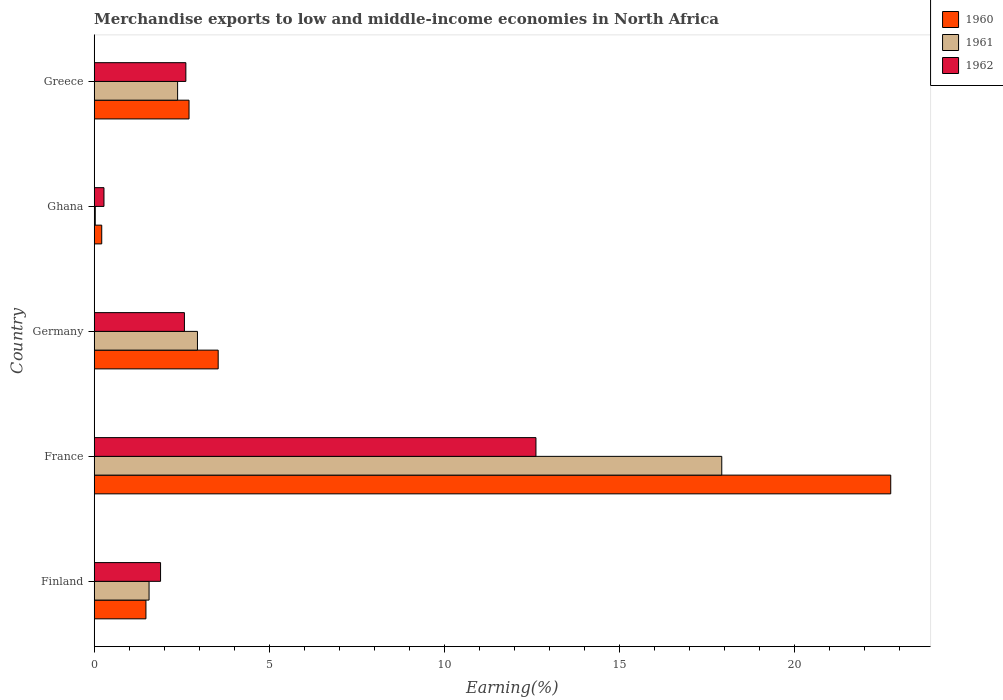How many different coloured bars are there?
Make the answer very short. 3. How many groups of bars are there?
Offer a terse response. 5. Are the number of bars per tick equal to the number of legend labels?
Your answer should be very brief. Yes. How many bars are there on the 3rd tick from the bottom?
Your answer should be very brief. 3. What is the percentage of amount earned from merchandise exports in 1960 in Greece?
Ensure brevity in your answer.  2.71. Across all countries, what is the maximum percentage of amount earned from merchandise exports in 1960?
Your response must be concise. 22.75. Across all countries, what is the minimum percentage of amount earned from merchandise exports in 1961?
Your answer should be compact. 0.03. In which country was the percentage of amount earned from merchandise exports in 1962 maximum?
Your answer should be very brief. France. In which country was the percentage of amount earned from merchandise exports in 1961 minimum?
Your answer should be compact. Ghana. What is the total percentage of amount earned from merchandise exports in 1960 in the graph?
Your answer should be compact. 30.69. What is the difference between the percentage of amount earned from merchandise exports in 1960 in France and that in Greece?
Provide a short and direct response. 20.04. What is the difference between the percentage of amount earned from merchandise exports in 1961 in France and the percentage of amount earned from merchandise exports in 1960 in Finland?
Ensure brevity in your answer.  16.44. What is the average percentage of amount earned from merchandise exports in 1960 per country?
Ensure brevity in your answer.  6.14. What is the difference between the percentage of amount earned from merchandise exports in 1961 and percentage of amount earned from merchandise exports in 1960 in Ghana?
Provide a short and direct response. -0.18. What is the ratio of the percentage of amount earned from merchandise exports in 1961 in Ghana to that in Greece?
Make the answer very short. 0.01. What is the difference between the highest and the second highest percentage of amount earned from merchandise exports in 1962?
Ensure brevity in your answer.  10. What is the difference between the highest and the lowest percentage of amount earned from merchandise exports in 1962?
Your answer should be compact. 12.34. In how many countries, is the percentage of amount earned from merchandise exports in 1961 greater than the average percentage of amount earned from merchandise exports in 1961 taken over all countries?
Your answer should be compact. 1. Is it the case that in every country, the sum of the percentage of amount earned from merchandise exports in 1960 and percentage of amount earned from merchandise exports in 1961 is greater than the percentage of amount earned from merchandise exports in 1962?
Ensure brevity in your answer.  No. How many bars are there?
Your answer should be compact. 15. How many countries are there in the graph?
Ensure brevity in your answer.  5. What is the difference between two consecutive major ticks on the X-axis?
Offer a terse response. 5. Does the graph contain any zero values?
Give a very brief answer. No. How are the legend labels stacked?
Give a very brief answer. Vertical. What is the title of the graph?
Provide a succinct answer. Merchandise exports to low and middle-income economies in North Africa. What is the label or title of the X-axis?
Keep it short and to the point. Earning(%). What is the Earning(%) in 1960 in Finland?
Your answer should be compact. 1.48. What is the Earning(%) in 1961 in Finland?
Make the answer very short. 1.57. What is the Earning(%) in 1962 in Finland?
Keep it short and to the point. 1.9. What is the Earning(%) in 1960 in France?
Provide a short and direct response. 22.75. What is the Earning(%) of 1961 in France?
Your answer should be very brief. 17.92. What is the Earning(%) in 1962 in France?
Offer a terse response. 12.62. What is the Earning(%) of 1960 in Germany?
Your answer should be compact. 3.54. What is the Earning(%) in 1961 in Germany?
Your response must be concise. 2.95. What is the Earning(%) of 1962 in Germany?
Your response must be concise. 2.58. What is the Earning(%) of 1960 in Ghana?
Your answer should be compact. 0.22. What is the Earning(%) in 1961 in Ghana?
Provide a short and direct response. 0.03. What is the Earning(%) in 1962 in Ghana?
Offer a terse response. 0.28. What is the Earning(%) in 1960 in Greece?
Provide a short and direct response. 2.71. What is the Earning(%) of 1961 in Greece?
Provide a short and direct response. 2.38. What is the Earning(%) of 1962 in Greece?
Your answer should be very brief. 2.62. Across all countries, what is the maximum Earning(%) of 1960?
Keep it short and to the point. 22.75. Across all countries, what is the maximum Earning(%) in 1961?
Keep it short and to the point. 17.92. Across all countries, what is the maximum Earning(%) of 1962?
Provide a short and direct response. 12.62. Across all countries, what is the minimum Earning(%) in 1960?
Offer a terse response. 0.22. Across all countries, what is the minimum Earning(%) in 1961?
Your answer should be very brief. 0.03. Across all countries, what is the minimum Earning(%) of 1962?
Provide a succinct answer. 0.28. What is the total Earning(%) of 1960 in the graph?
Make the answer very short. 30.69. What is the total Earning(%) of 1961 in the graph?
Keep it short and to the point. 24.85. What is the total Earning(%) in 1962 in the graph?
Give a very brief answer. 19.98. What is the difference between the Earning(%) of 1960 in Finland and that in France?
Make the answer very short. -21.27. What is the difference between the Earning(%) in 1961 in Finland and that in France?
Keep it short and to the point. -16.36. What is the difference between the Earning(%) in 1962 in Finland and that in France?
Your answer should be compact. -10.72. What is the difference between the Earning(%) of 1960 in Finland and that in Germany?
Your answer should be compact. -2.06. What is the difference between the Earning(%) of 1961 in Finland and that in Germany?
Your answer should be very brief. -1.38. What is the difference between the Earning(%) of 1962 in Finland and that in Germany?
Offer a terse response. -0.68. What is the difference between the Earning(%) of 1960 in Finland and that in Ghana?
Your response must be concise. 1.26. What is the difference between the Earning(%) of 1961 in Finland and that in Ghana?
Offer a terse response. 1.54. What is the difference between the Earning(%) of 1962 in Finland and that in Ghana?
Offer a very short reply. 1.62. What is the difference between the Earning(%) of 1960 in Finland and that in Greece?
Provide a succinct answer. -1.23. What is the difference between the Earning(%) of 1961 in Finland and that in Greece?
Give a very brief answer. -0.82. What is the difference between the Earning(%) in 1962 in Finland and that in Greece?
Provide a succinct answer. -0.72. What is the difference between the Earning(%) of 1960 in France and that in Germany?
Ensure brevity in your answer.  19.21. What is the difference between the Earning(%) of 1961 in France and that in Germany?
Your response must be concise. 14.97. What is the difference between the Earning(%) in 1962 in France and that in Germany?
Keep it short and to the point. 10.04. What is the difference between the Earning(%) of 1960 in France and that in Ghana?
Keep it short and to the point. 22.53. What is the difference between the Earning(%) of 1961 in France and that in Ghana?
Give a very brief answer. 17.89. What is the difference between the Earning(%) of 1962 in France and that in Ghana?
Offer a very short reply. 12.34. What is the difference between the Earning(%) in 1960 in France and that in Greece?
Give a very brief answer. 20.04. What is the difference between the Earning(%) of 1961 in France and that in Greece?
Provide a succinct answer. 15.54. What is the difference between the Earning(%) of 1962 in France and that in Greece?
Your answer should be very brief. 10. What is the difference between the Earning(%) in 1960 in Germany and that in Ghana?
Provide a short and direct response. 3.33. What is the difference between the Earning(%) in 1961 in Germany and that in Ghana?
Provide a short and direct response. 2.92. What is the difference between the Earning(%) of 1962 in Germany and that in Ghana?
Give a very brief answer. 2.3. What is the difference between the Earning(%) of 1960 in Germany and that in Greece?
Your response must be concise. 0.83. What is the difference between the Earning(%) of 1961 in Germany and that in Greece?
Ensure brevity in your answer.  0.57. What is the difference between the Earning(%) of 1962 in Germany and that in Greece?
Your answer should be compact. -0.04. What is the difference between the Earning(%) in 1960 in Ghana and that in Greece?
Keep it short and to the point. -2.49. What is the difference between the Earning(%) in 1961 in Ghana and that in Greece?
Provide a short and direct response. -2.35. What is the difference between the Earning(%) in 1962 in Ghana and that in Greece?
Provide a short and direct response. -2.34. What is the difference between the Earning(%) in 1960 in Finland and the Earning(%) in 1961 in France?
Provide a succinct answer. -16.44. What is the difference between the Earning(%) in 1960 in Finland and the Earning(%) in 1962 in France?
Make the answer very short. -11.14. What is the difference between the Earning(%) of 1961 in Finland and the Earning(%) of 1962 in France?
Your answer should be very brief. -11.05. What is the difference between the Earning(%) of 1960 in Finland and the Earning(%) of 1961 in Germany?
Offer a very short reply. -1.47. What is the difference between the Earning(%) of 1960 in Finland and the Earning(%) of 1962 in Germany?
Your answer should be compact. -1.1. What is the difference between the Earning(%) of 1961 in Finland and the Earning(%) of 1962 in Germany?
Your response must be concise. -1.01. What is the difference between the Earning(%) of 1960 in Finland and the Earning(%) of 1961 in Ghana?
Your answer should be very brief. 1.45. What is the difference between the Earning(%) in 1960 in Finland and the Earning(%) in 1962 in Ghana?
Make the answer very short. 1.2. What is the difference between the Earning(%) of 1961 in Finland and the Earning(%) of 1962 in Ghana?
Provide a succinct answer. 1.29. What is the difference between the Earning(%) of 1960 in Finland and the Earning(%) of 1961 in Greece?
Give a very brief answer. -0.9. What is the difference between the Earning(%) of 1960 in Finland and the Earning(%) of 1962 in Greece?
Your answer should be compact. -1.14. What is the difference between the Earning(%) in 1961 in Finland and the Earning(%) in 1962 in Greece?
Your answer should be compact. -1.05. What is the difference between the Earning(%) in 1960 in France and the Earning(%) in 1961 in Germany?
Your answer should be very brief. 19.8. What is the difference between the Earning(%) in 1960 in France and the Earning(%) in 1962 in Germany?
Ensure brevity in your answer.  20.17. What is the difference between the Earning(%) in 1961 in France and the Earning(%) in 1962 in Germany?
Your answer should be very brief. 15.35. What is the difference between the Earning(%) of 1960 in France and the Earning(%) of 1961 in Ghana?
Your answer should be compact. 22.72. What is the difference between the Earning(%) of 1960 in France and the Earning(%) of 1962 in Ghana?
Your response must be concise. 22.47. What is the difference between the Earning(%) of 1961 in France and the Earning(%) of 1962 in Ghana?
Give a very brief answer. 17.64. What is the difference between the Earning(%) of 1960 in France and the Earning(%) of 1961 in Greece?
Keep it short and to the point. 20.37. What is the difference between the Earning(%) in 1960 in France and the Earning(%) in 1962 in Greece?
Offer a very short reply. 20.13. What is the difference between the Earning(%) in 1961 in France and the Earning(%) in 1962 in Greece?
Keep it short and to the point. 15.3. What is the difference between the Earning(%) in 1960 in Germany and the Earning(%) in 1961 in Ghana?
Make the answer very short. 3.51. What is the difference between the Earning(%) of 1960 in Germany and the Earning(%) of 1962 in Ghana?
Make the answer very short. 3.26. What is the difference between the Earning(%) of 1961 in Germany and the Earning(%) of 1962 in Ghana?
Your answer should be very brief. 2.67. What is the difference between the Earning(%) of 1960 in Germany and the Earning(%) of 1961 in Greece?
Offer a very short reply. 1.16. What is the difference between the Earning(%) of 1960 in Germany and the Earning(%) of 1962 in Greece?
Your answer should be compact. 0.92. What is the difference between the Earning(%) of 1961 in Germany and the Earning(%) of 1962 in Greece?
Give a very brief answer. 0.33. What is the difference between the Earning(%) of 1960 in Ghana and the Earning(%) of 1961 in Greece?
Your answer should be compact. -2.17. What is the difference between the Earning(%) in 1960 in Ghana and the Earning(%) in 1962 in Greece?
Your answer should be compact. -2.4. What is the difference between the Earning(%) of 1961 in Ghana and the Earning(%) of 1962 in Greece?
Your answer should be compact. -2.59. What is the average Earning(%) of 1960 per country?
Keep it short and to the point. 6.14. What is the average Earning(%) in 1961 per country?
Offer a very short reply. 4.97. What is the average Earning(%) in 1962 per country?
Give a very brief answer. 4. What is the difference between the Earning(%) of 1960 and Earning(%) of 1961 in Finland?
Your answer should be very brief. -0.09. What is the difference between the Earning(%) of 1960 and Earning(%) of 1962 in Finland?
Provide a succinct answer. -0.42. What is the difference between the Earning(%) of 1961 and Earning(%) of 1962 in Finland?
Keep it short and to the point. -0.33. What is the difference between the Earning(%) of 1960 and Earning(%) of 1961 in France?
Provide a short and direct response. 4.83. What is the difference between the Earning(%) of 1960 and Earning(%) of 1962 in France?
Offer a very short reply. 10.13. What is the difference between the Earning(%) of 1961 and Earning(%) of 1962 in France?
Provide a short and direct response. 5.31. What is the difference between the Earning(%) of 1960 and Earning(%) of 1961 in Germany?
Your answer should be compact. 0.59. What is the difference between the Earning(%) of 1960 and Earning(%) of 1962 in Germany?
Provide a succinct answer. 0.96. What is the difference between the Earning(%) in 1961 and Earning(%) in 1962 in Germany?
Make the answer very short. 0.37. What is the difference between the Earning(%) in 1960 and Earning(%) in 1961 in Ghana?
Keep it short and to the point. 0.18. What is the difference between the Earning(%) in 1960 and Earning(%) in 1962 in Ghana?
Ensure brevity in your answer.  -0.06. What is the difference between the Earning(%) in 1961 and Earning(%) in 1962 in Ghana?
Keep it short and to the point. -0.25. What is the difference between the Earning(%) of 1960 and Earning(%) of 1961 in Greece?
Ensure brevity in your answer.  0.33. What is the difference between the Earning(%) in 1960 and Earning(%) in 1962 in Greece?
Provide a short and direct response. 0.09. What is the difference between the Earning(%) of 1961 and Earning(%) of 1962 in Greece?
Keep it short and to the point. -0.24. What is the ratio of the Earning(%) of 1960 in Finland to that in France?
Offer a terse response. 0.07. What is the ratio of the Earning(%) in 1961 in Finland to that in France?
Offer a very short reply. 0.09. What is the ratio of the Earning(%) in 1962 in Finland to that in France?
Your answer should be very brief. 0.15. What is the ratio of the Earning(%) in 1960 in Finland to that in Germany?
Your response must be concise. 0.42. What is the ratio of the Earning(%) of 1961 in Finland to that in Germany?
Your response must be concise. 0.53. What is the ratio of the Earning(%) of 1962 in Finland to that in Germany?
Offer a very short reply. 0.74. What is the ratio of the Earning(%) in 1960 in Finland to that in Ghana?
Your answer should be very brief. 6.86. What is the ratio of the Earning(%) of 1961 in Finland to that in Ghana?
Ensure brevity in your answer.  50.5. What is the ratio of the Earning(%) of 1962 in Finland to that in Ghana?
Offer a very short reply. 6.79. What is the ratio of the Earning(%) of 1960 in Finland to that in Greece?
Offer a terse response. 0.55. What is the ratio of the Earning(%) of 1961 in Finland to that in Greece?
Provide a short and direct response. 0.66. What is the ratio of the Earning(%) in 1962 in Finland to that in Greece?
Give a very brief answer. 0.72. What is the ratio of the Earning(%) in 1960 in France to that in Germany?
Offer a very short reply. 6.42. What is the ratio of the Earning(%) of 1961 in France to that in Germany?
Offer a terse response. 6.08. What is the ratio of the Earning(%) of 1962 in France to that in Germany?
Your answer should be compact. 4.9. What is the ratio of the Earning(%) in 1960 in France to that in Ghana?
Make the answer very short. 105.68. What is the ratio of the Earning(%) in 1961 in France to that in Ghana?
Offer a terse response. 577.63. What is the ratio of the Earning(%) of 1962 in France to that in Ghana?
Give a very brief answer. 45.22. What is the ratio of the Earning(%) in 1960 in France to that in Greece?
Offer a terse response. 8.4. What is the ratio of the Earning(%) of 1961 in France to that in Greece?
Provide a short and direct response. 7.52. What is the ratio of the Earning(%) of 1962 in France to that in Greece?
Offer a very short reply. 4.82. What is the ratio of the Earning(%) in 1960 in Germany to that in Ghana?
Ensure brevity in your answer.  16.45. What is the ratio of the Earning(%) in 1961 in Germany to that in Ghana?
Give a very brief answer. 95.03. What is the ratio of the Earning(%) of 1962 in Germany to that in Ghana?
Make the answer very short. 9.24. What is the ratio of the Earning(%) of 1960 in Germany to that in Greece?
Your answer should be very brief. 1.31. What is the ratio of the Earning(%) of 1961 in Germany to that in Greece?
Your answer should be compact. 1.24. What is the ratio of the Earning(%) of 1962 in Germany to that in Greece?
Make the answer very short. 0.98. What is the ratio of the Earning(%) in 1960 in Ghana to that in Greece?
Make the answer very short. 0.08. What is the ratio of the Earning(%) in 1961 in Ghana to that in Greece?
Provide a succinct answer. 0.01. What is the ratio of the Earning(%) in 1962 in Ghana to that in Greece?
Offer a terse response. 0.11. What is the difference between the highest and the second highest Earning(%) in 1960?
Your response must be concise. 19.21. What is the difference between the highest and the second highest Earning(%) of 1961?
Offer a very short reply. 14.97. What is the difference between the highest and the second highest Earning(%) in 1962?
Offer a very short reply. 10. What is the difference between the highest and the lowest Earning(%) of 1960?
Make the answer very short. 22.53. What is the difference between the highest and the lowest Earning(%) of 1961?
Offer a very short reply. 17.89. What is the difference between the highest and the lowest Earning(%) in 1962?
Your answer should be compact. 12.34. 